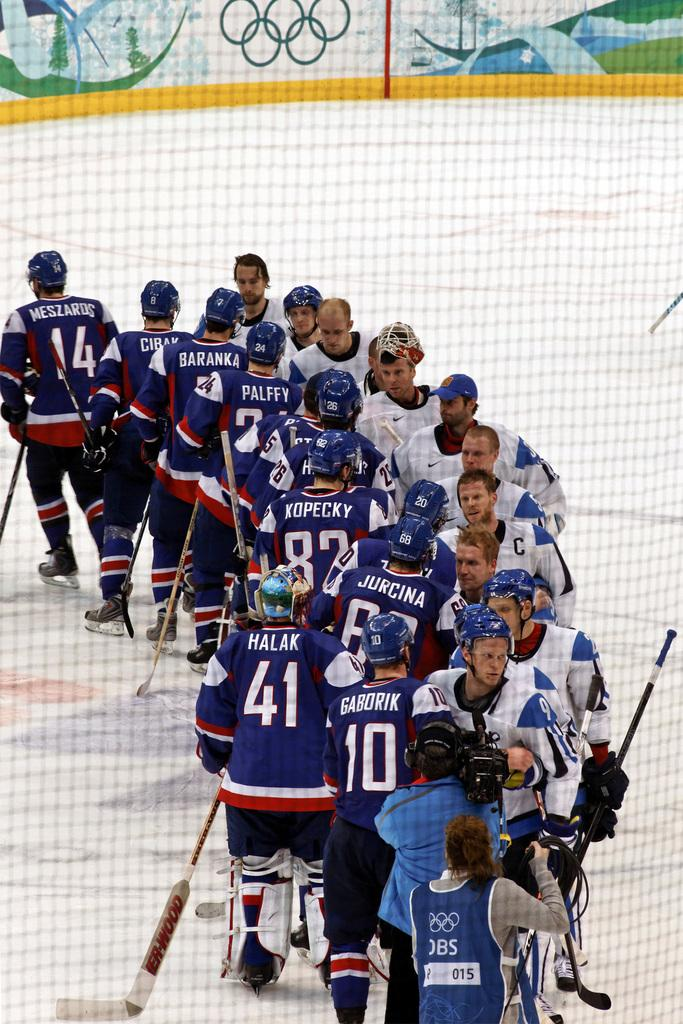<image>
Write a terse but informative summary of the picture. Opposing ice hockey players are in line shaking hands, player Meszards has finished and is skating away. 